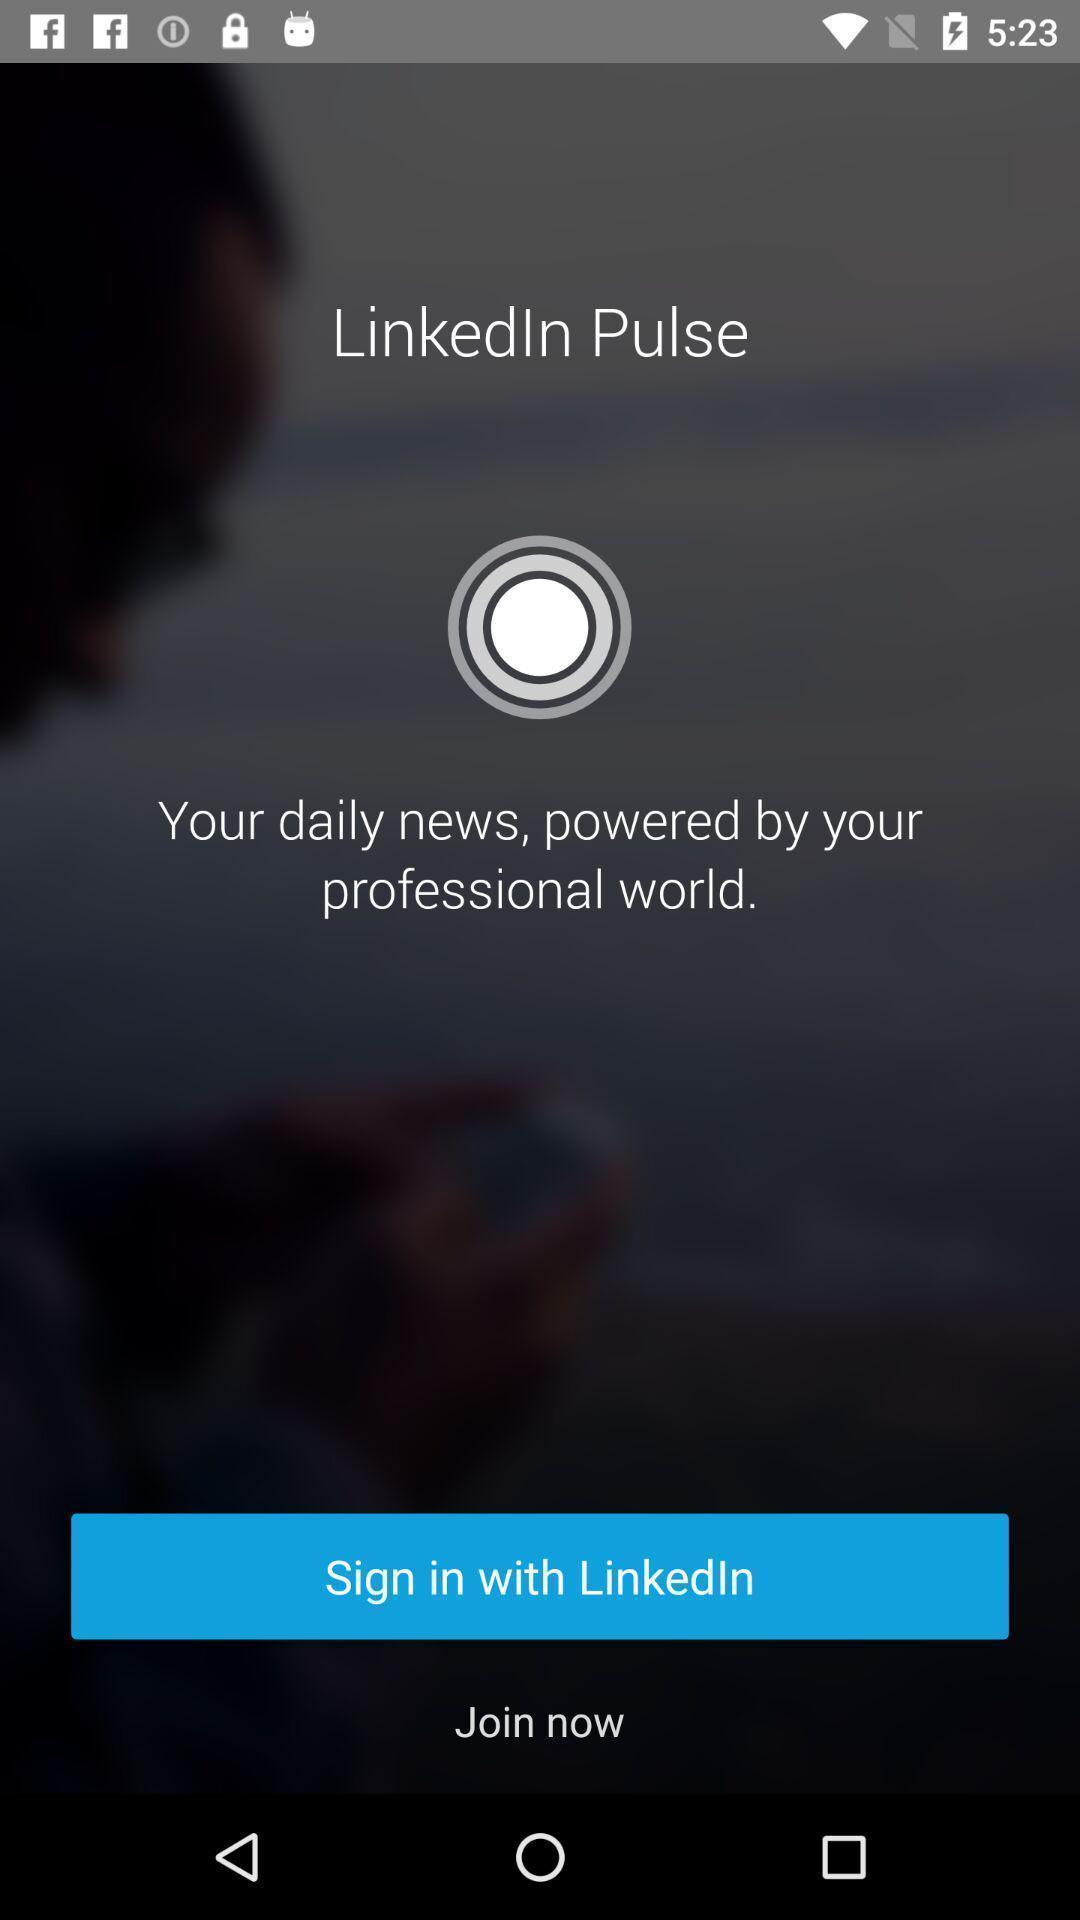Describe the key features of this screenshot. Welcome page. 